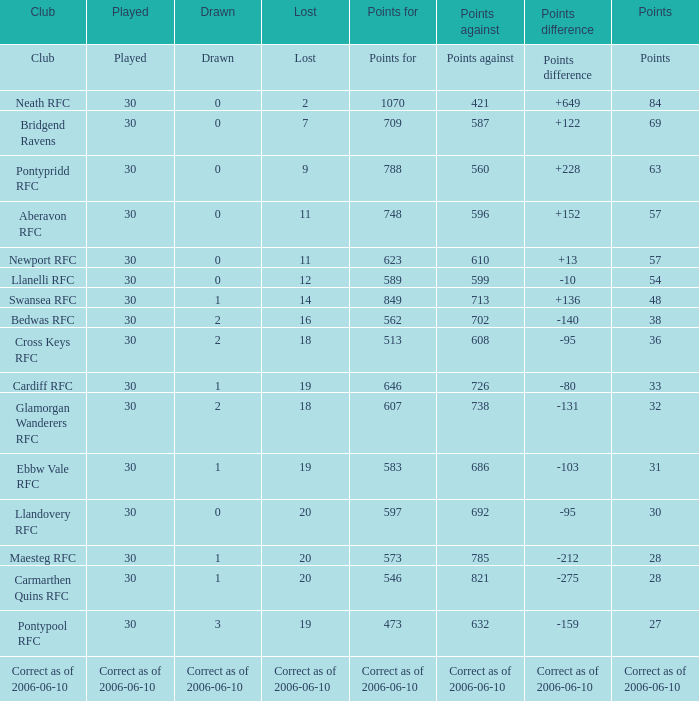What is Drawn, when Played is "Correct as of 2006-06-10"? Correct as of 2006-06-10. 